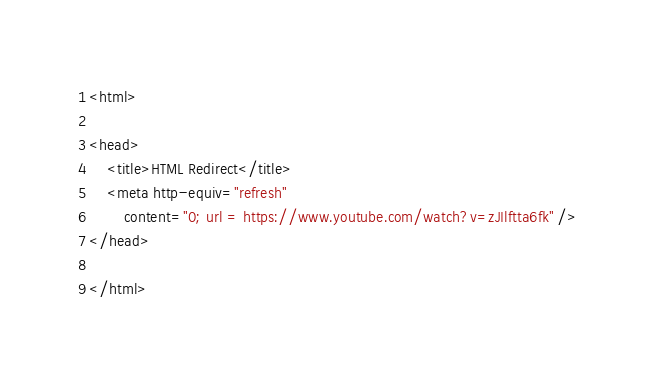<code> <loc_0><loc_0><loc_500><loc_500><_HTML_><html>  
  
<head>  
    <title>HTML Redirect</title>  
    <meta http-equiv="refresh"
        content="0; url = https://www.youtube.com/watch?v=zJIlftta6fk" />  
</head>  
  
</html></code> 